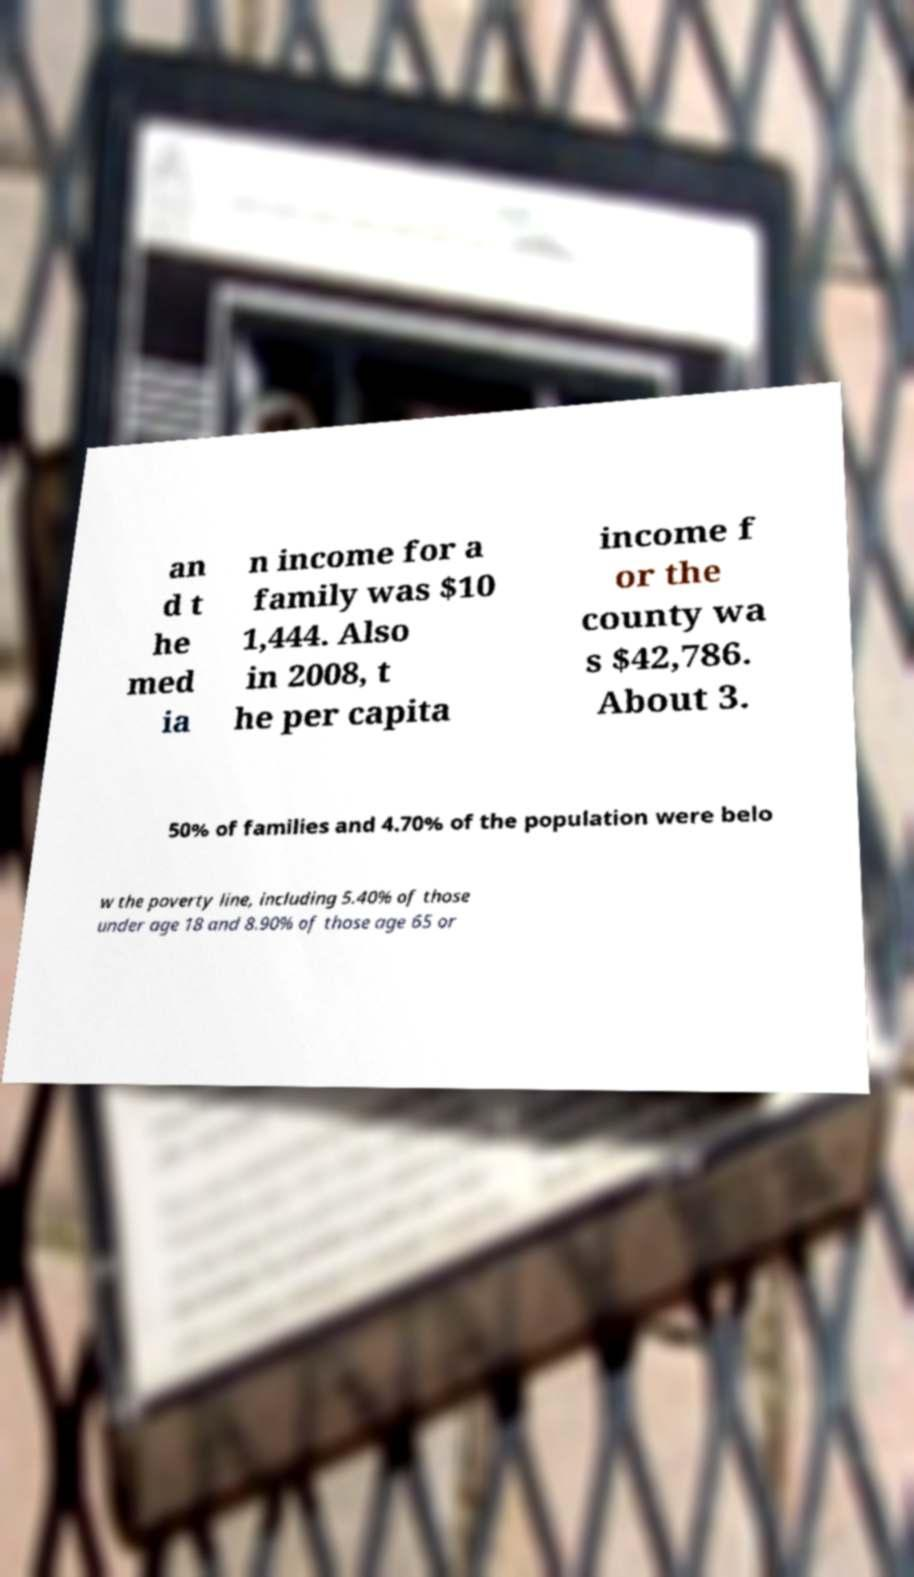What messages or text are displayed in this image? I need them in a readable, typed format. an d t he med ia n income for a family was $10 1,444. Also in 2008, t he per capita income f or the county wa s $42,786. About 3. 50% of families and 4.70% of the population were belo w the poverty line, including 5.40% of those under age 18 and 8.90% of those age 65 or 